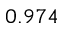Convert formula to latex. <formula><loc_0><loc_0><loc_500><loc_500>0 . 9 7 4</formula> 